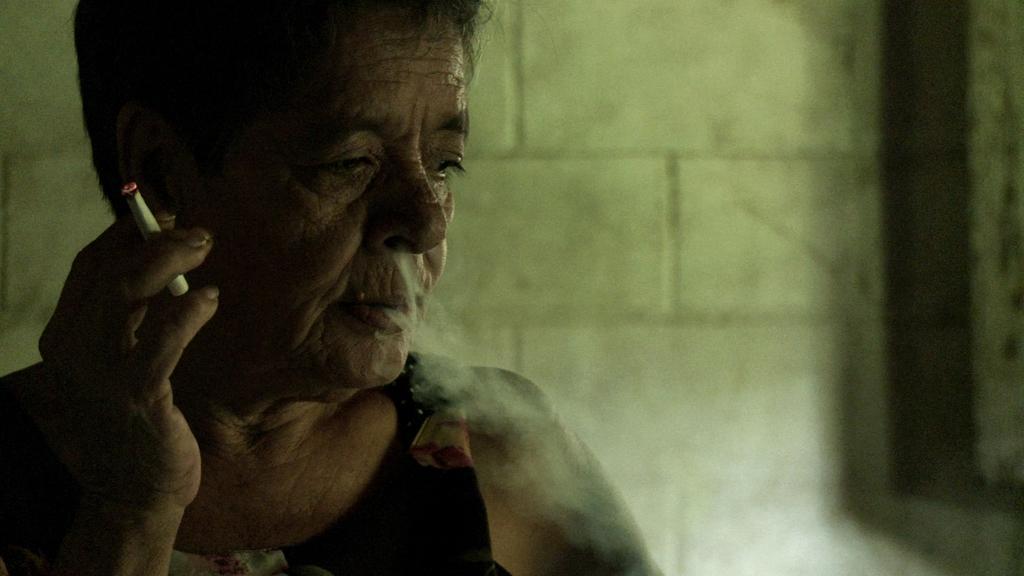In one or two sentences, can you explain what this image depicts? In this image we can see a man on the left side and he is holding a cigarette in his fingers and there is smoke coming out from his nose and mouth. In the background we can see the wall. 